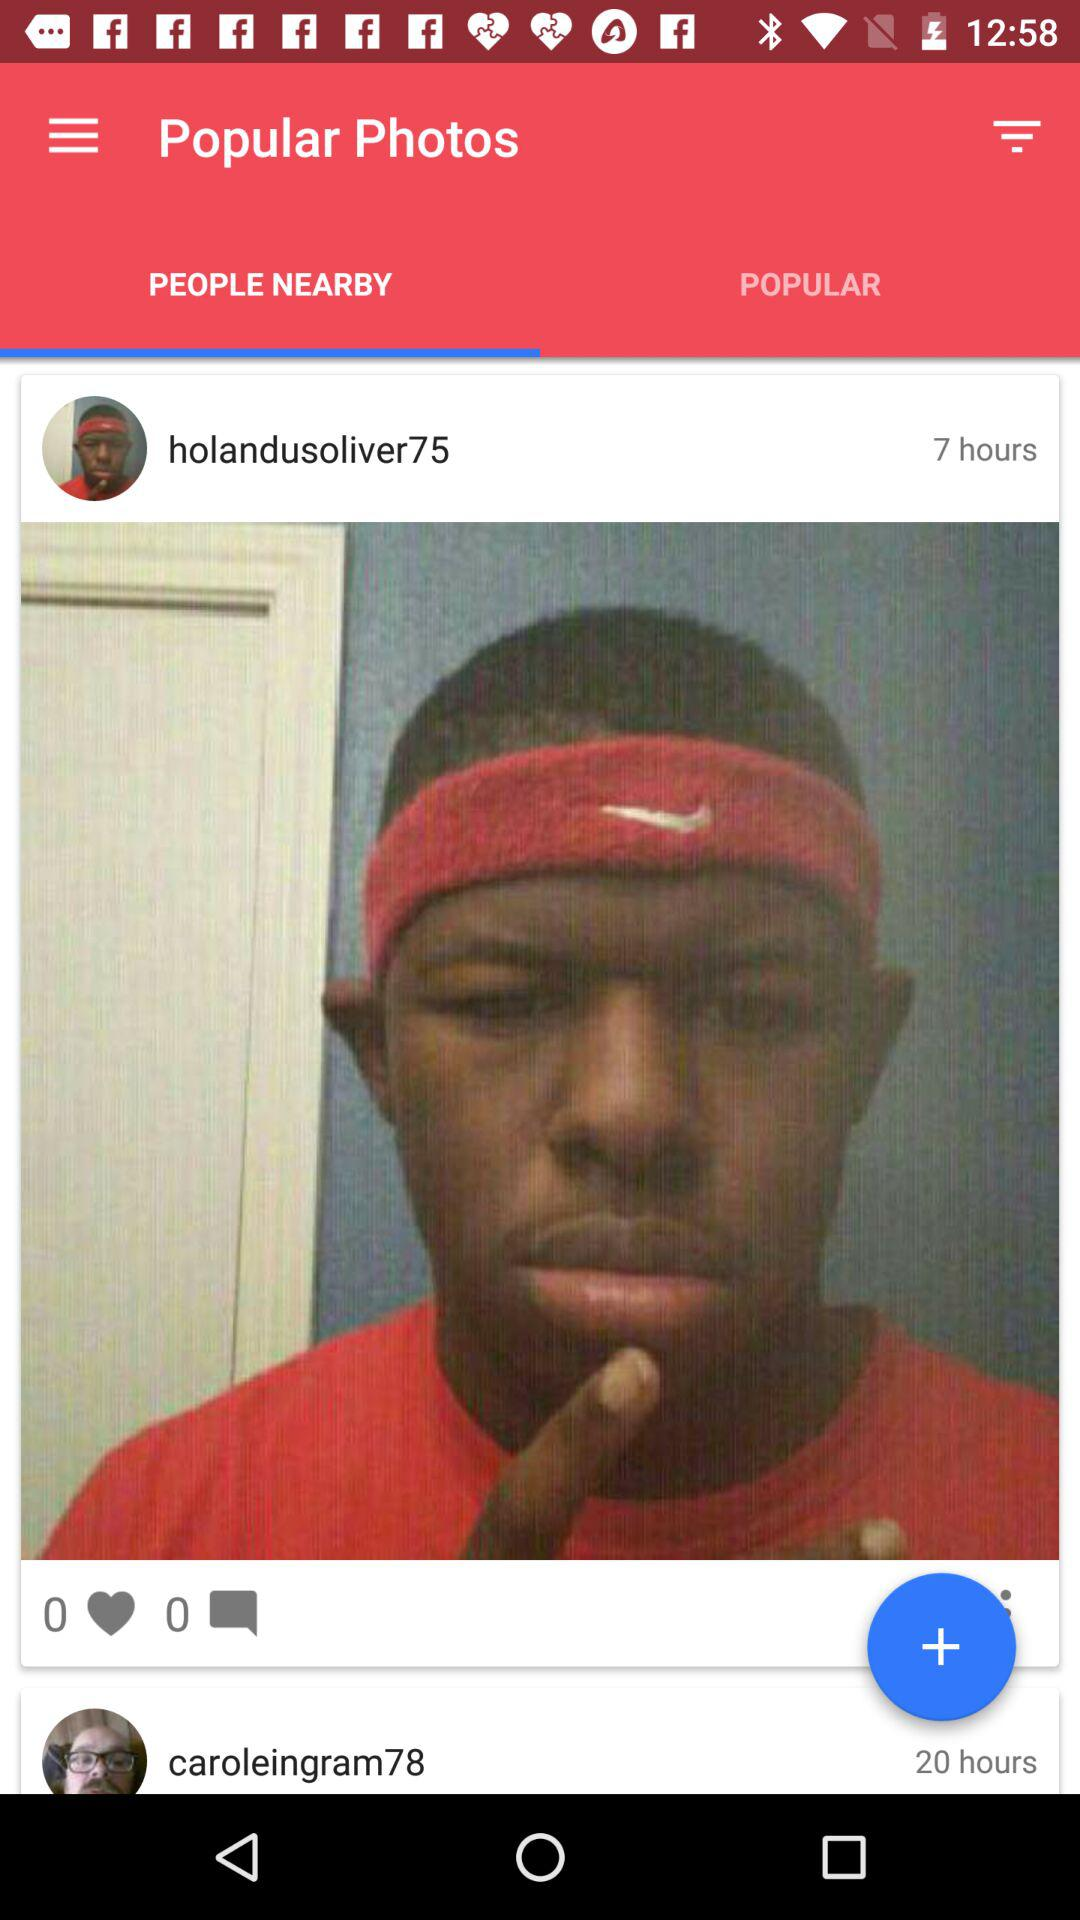On which tab am I now? You are now on the "PEOPLE NEARBY" tab. 